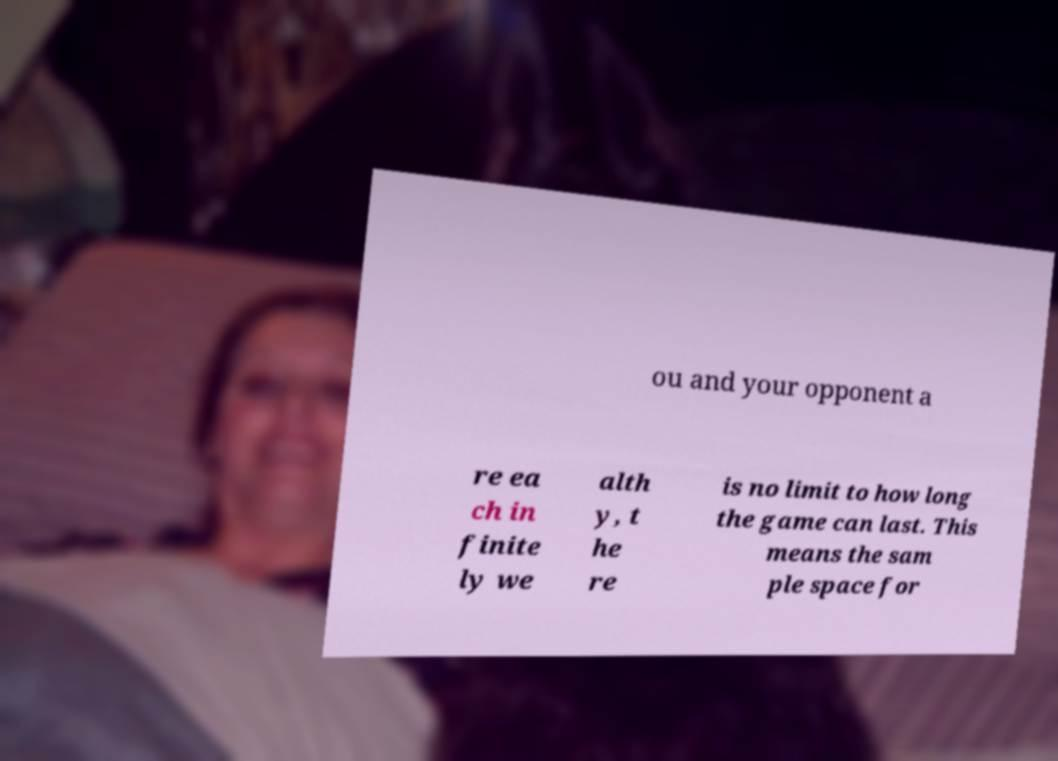For documentation purposes, I need the text within this image transcribed. Could you provide that? ou and your opponent a re ea ch in finite ly we alth y, t he re is no limit to how long the game can last. This means the sam ple space for 